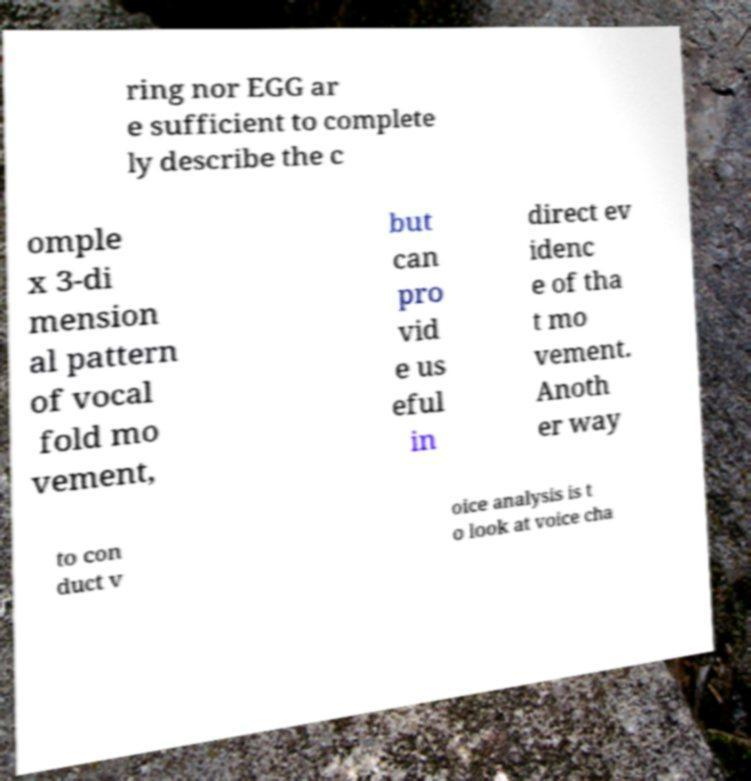Please identify and transcribe the text found in this image. ring nor EGG ar e sufficient to complete ly describe the c omple x 3-di mension al pattern of vocal fold mo vement, but can pro vid e us eful in direct ev idenc e of tha t mo vement. Anoth er way to con duct v oice analysis is t o look at voice cha 